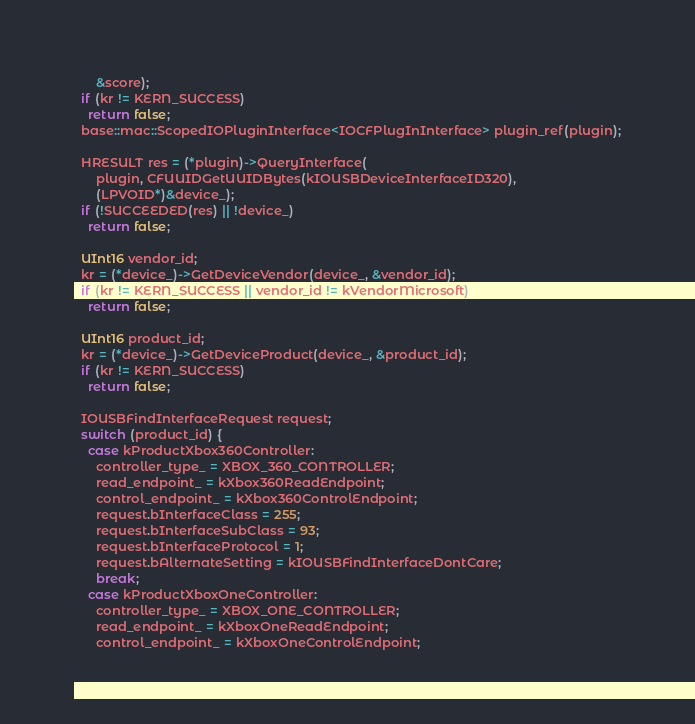<code> <loc_0><loc_0><loc_500><loc_500><_ObjectiveC_>      &score);
  if (kr != KERN_SUCCESS)
    return false;
  base::mac::ScopedIOPluginInterface<IOCFPlugInInterface> plugin_ref(plugin);

  HRESULT res = (*plugin)->QueryInterface(
      plugin, CFUUIDGetUUIDBytes(kIOUSBDeviceInterfaceID320),
      (LPVOID*)&device_);
  if (!SUCCEEDED(res) || !device_)
    return false;

  UInt16 vendor_id;
  kr = (*device_)->GetDeviceVendor(device_, &vendor_id);
  if (kr != KERN_SUCCESS || vendor_id != kVendorMicrosoft)
    return false;

  UInt16 product_id;
  kr = (*device_)->GetDeviceProduct(device_, &product_id);
  if (kr != KERN_SUCCESS)
    return false;

  IOUSBFindInterfaceRequest request;
  switch (product_id) {
    case kProductXbox360Controller:
      controller_type_ = XBOX_360_CONTROLLER;
      read_endpoint_ = kXbox360ReadEndpoint;
      control_endpoint_ = kXbox360ControlEndpoint;
      request.bInterfaceClass = 255;
      request.bInterfaceSubClass = 93;
      request.bInterfaceProtocol = 1;
      request.bAlternateSetting = kIOUSBFindInterfaceDontCare;
      break;
    case kProductXboxOneController:
      controller_type_ = XBOX_ONE_CONTROLLER;
      read_endpoint_ = kXboxOneReadEndpoint;
      control_endpoint_ = kXboxOneControlEndpoint;</code> 